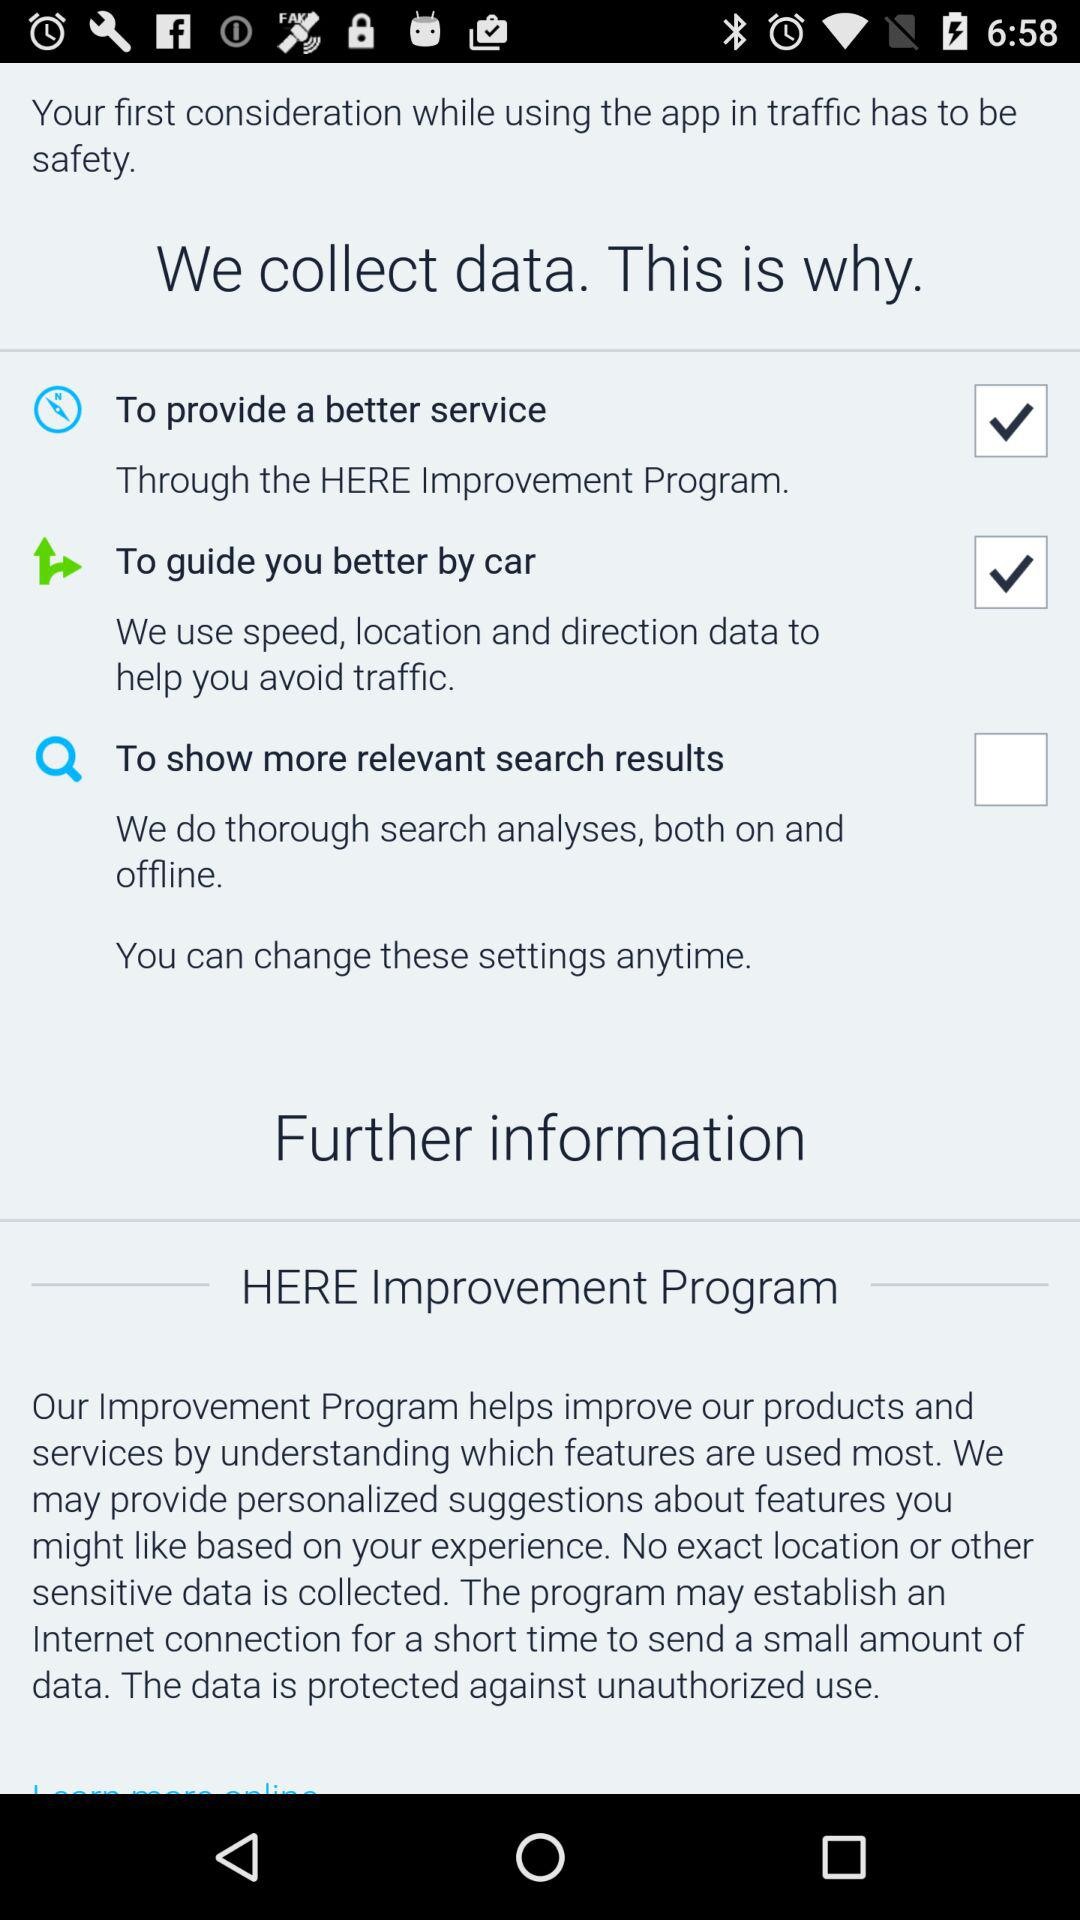How many data collection purposes are mentioned in the text?
Answer the question using a single word or phrase. 3 